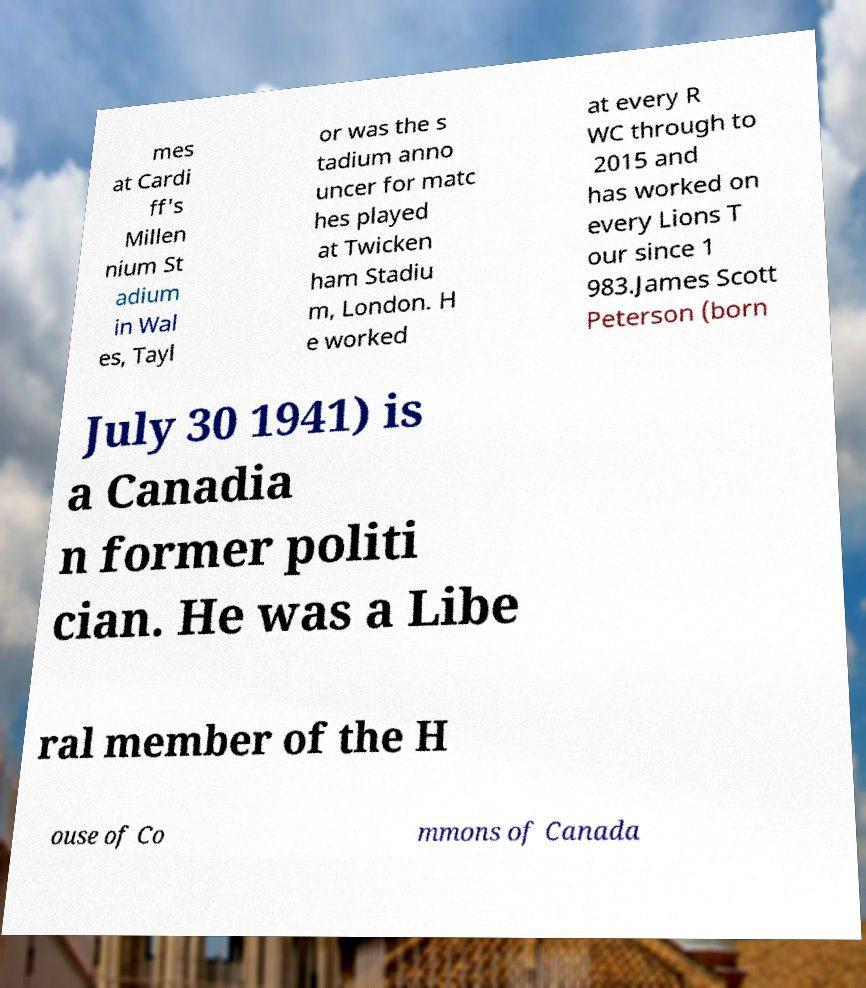There's text embedded in this image that I need extracted. Can you transcribe it verbatim? mes at Cardi ff's Millen nium St adium in Wal es, Tayl or was the s tadium anno uncer for matc hes played at Twicken ham Stadiu m, London. H e worked at every R WC through to 2015 and has worked on every Lions T our since 1 983.James Scott Peterson (born July 30 1941) is a Canadia n former politi cian. He was a Libe ral member of the H ouse of Co mmons of Canada 